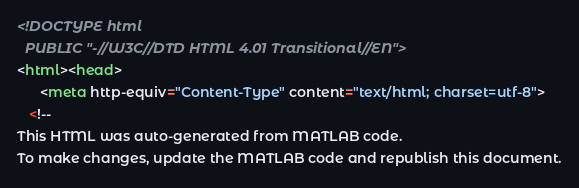Convert code to text. <code><loc_0><loc_0><loc_500><loc_500><_HTML_>
<!DOCTYPE html
  PUBLIC "-//W3C//DTD HTML 4.01 Transitional//EN">
<html><head>
      <meta http-equiv="Content-Type" content="text/html; charset=utf-8">
   <!--
This HTML was auto-generated from MATLAB code.
To make changes, update the MATLAB code and republish this document.</code> 